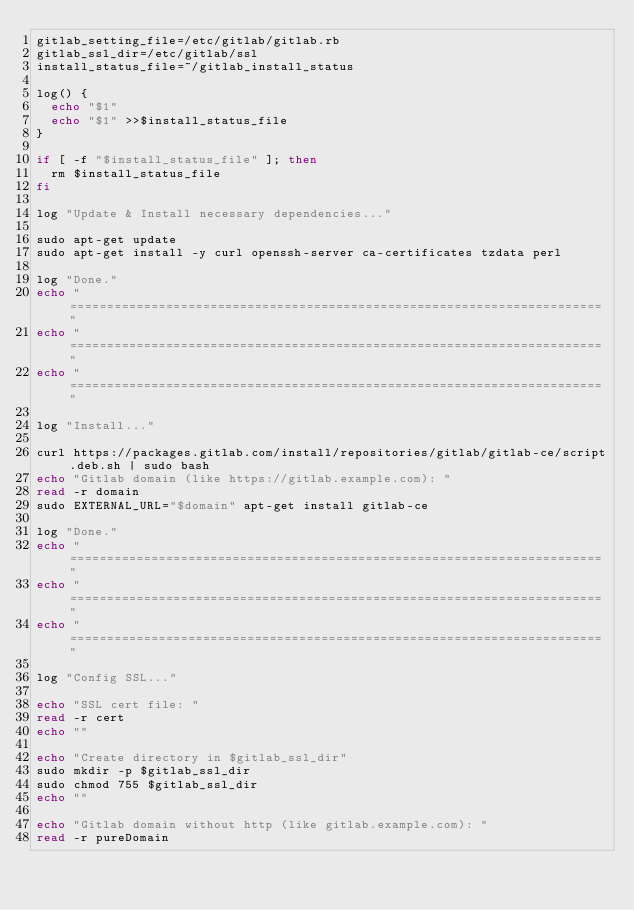<code> <loc_0><loc_0><loc_500><loc_500><_Bash_>gitlab_setting_file=/etc/gitlab/gitlab.rb
gitlab_ssl_dir=/etc/gitlab/ssl
install_status_file=~/gitlab_install_status

log() {
  echo "$1"
  echo "$1" >>$install_status_file
}

if [ -f "$install_status_file" ]; then
  rm $install_status_file
fi

log "Update & Install necessary dependencies..."

sudo apt-get update
sudo apt-get install -y curl openssh-server ca-certificates tzdata perl

log "Done."
echo "========================================================================"
echo "========================================================================"
echo "========================================================================"

log "Install..."

curl https://packages.gitlab.com/install/repositories/gitlab/gitlab-ce/script.deb.sh | sudo bash
echo "Gitlab domain (like https://gitlab.example.com): "
read -r domain
sudo EXTERNAL_URL="$domain" apt-get install gitlab-ce

log "Done."
echo "========================================================================"
echo "========================================================================"
echo "========================================================================"

log "Config SSL..."

echo "SSL cert file: "
read -r cert
echo ""

echo "Create directory in $gitlab_ssl_dir"
sudo mkdir -p $gitlab_ssl_dir
sudo chmod 755 $gitlab_ssl_dir
echo ""

echo "Gitlab domain without http (like gitlab.example.com): "
read -r pureDomain</code> 